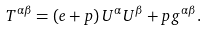<formula> <loc_0><loc_0><loc_500><loc_500>T ^ { \alpha \beta } = \left ( e + p \right ) U ^ { \alpha } U ^ { \beta } + p g ^ { \alpha \beta } .</formula> 